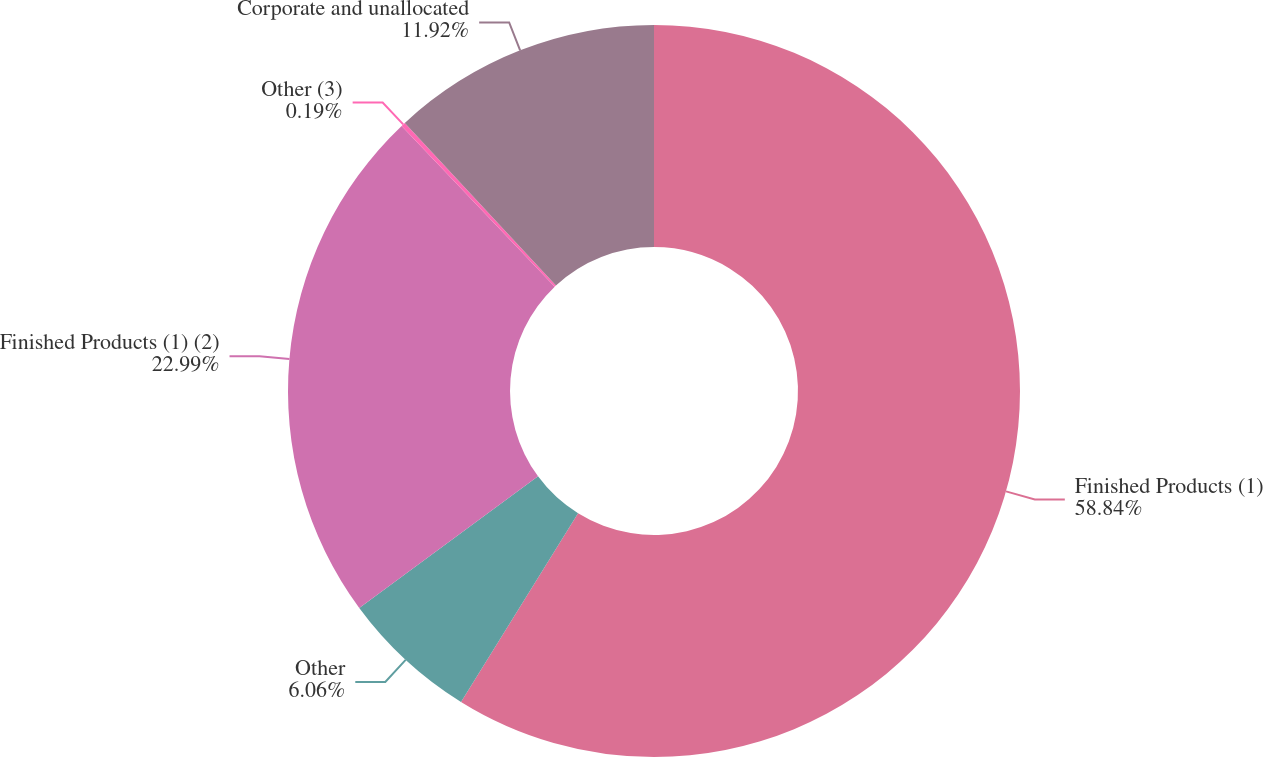Convert chart to OTSL. <chart><loc_0><loc_0><loc_500><loc_500><pie_chart><fcel>Finished Products (1)<fcel>Other<fcel>Finished Products (1) (2)<fcel>Other (3)<fcel>Corporate and unallocated<nl><fcel>58.84%<fcel>6.06%<fcel>22.99%<fcel>0.19%<fcel>11.92%<nl></chart> 